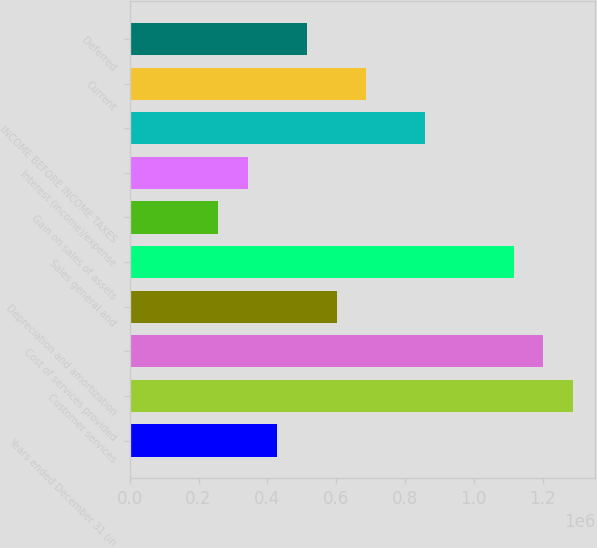Convert chart to OTSL. <chart><loc_0><loc_0><loc_500><loc_500><bar_chart><fcel>Years ended December 31 (in<fcel>Customer services<fcel>Cost of services provided<fcel>Depreciation and amortization<fcel>Sales general and<fcel>Gain on sales of assets<fcel>Interest (income)/expense<fcel>INCOME BEFORE INCOME TAXES<fcel>Current<fcel>Deferred<nl><fcel>429439<fcel>1.28832e+06<fcel>1.20243e+06<fcel>601215<fcel>1.11654e+06<fcel>257664<fcel>343551<fcel>858878<fcel>687102<fcel>515327<nl></chart> 